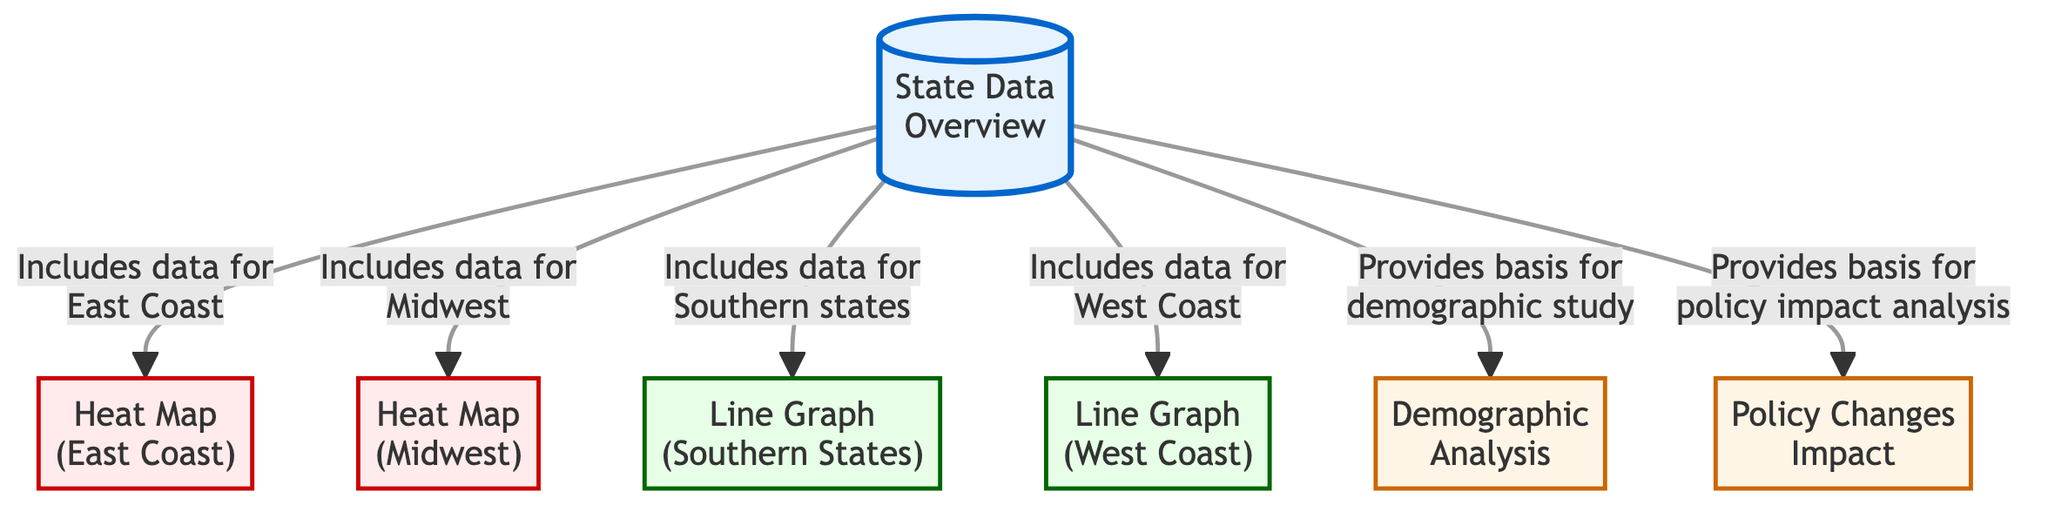What regions are included in the heat maps? The heat maps are specifically for the East Coast and the Midwest, as indicated in the diagram. Each heat map node specifically labels the region it represents.
Answer: East Coast, Midwest How many types of visualizations are used in the diagram? The diagram includes two types of visualizations: heat maps and line graphs. From the nodes, it’s easy to count these distinct visualization types.
Answer: Two Which analysis is based on demographic study? The diagram clearly links the state data overview to demographic analysis, indicating that this analysis is specifically based on the information presented.
Answer: Demographic Analysis What is the focus of the line graph for Southern States? The node specifically identifies that the line graph is concerned with the voting trends in Southern States, which can be found by scanning through the connections in the diagram.
Answer: Southern States Explain how policy changes impact is related to state data overview. The state data overview node is directly connected to the policy changes impact node, indicating that the data provides the foundation for understanding how these policies affect voter turnout and behaviors.
Answer: Provides basis for policy impact analysis What type of visualization represents the Midwest region? The Midwest region is represented by a heat map, as noted in the corresponding node connecting from the state data overview.
Answer: Heat Map Which region includes a line graph in the analysis? The West Coast is represented by the line graph in the analysis based on the direct connection from the state data overview node.
Answer: West Coast What insights are gathered from the demographic analysis? The demographic analysis has connections to the state data overview, implying it gathers insights regarding various demographic factors influencing voter turnout, as inferred from the structure of the diagram.
Answer: Voter Turnout Insights How many nodes represent heat maps in the diagram? There are two nodes that represent heat maps, specifically for the East Coast and Midwest, which can be counted from the diagram.
Answer: Two 